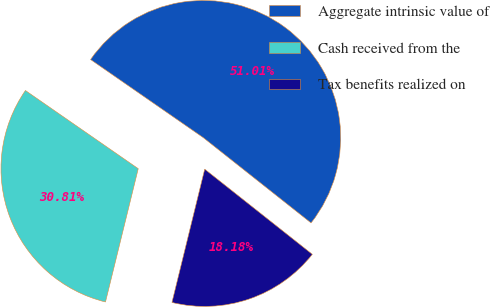Convert chart. <chart><loc_0><loc_0><loc_500><loc_500><pie_chart><fcel>Aggregate intrinsic value of<fcel>Cash received from the<fcel>Tax benefits realized on<nl><fcel>51.01%<fcel>30.81%<fcel>18.18%<nl></chart> 